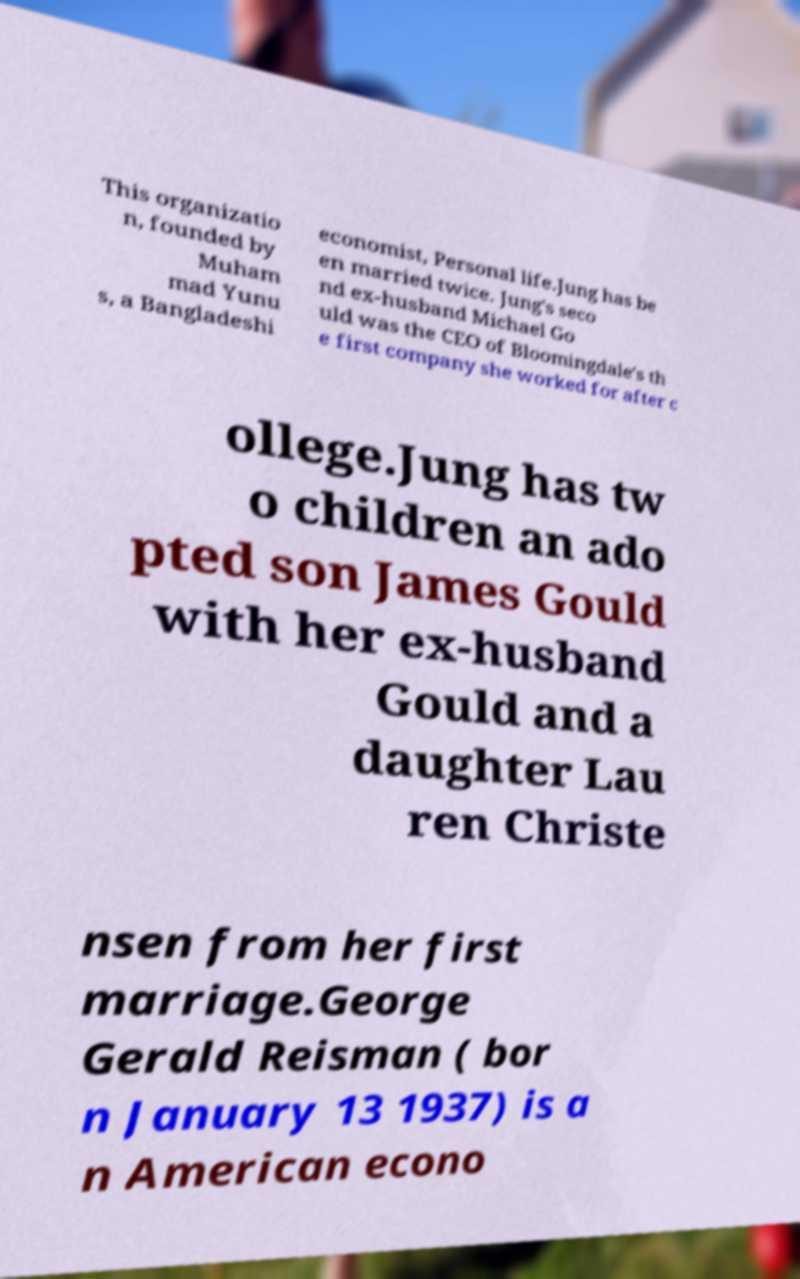Can you accurately transcribe the text from the provided image for me? This organizatio n, founded by Muham mad Yunu s, a Bangladeshi economist, Personal life.Jung has be en married twice. Jung's seco nd ex-husband Michael Go uld was the CEO of Bloomingdale's th e first company she worked for after c ollege.Jung has tw o children an ado pted son James Gould with her ex-husband Gould and a daughter Lau ren Christe nsen from her first marriage.George Gerald Reisman ( bor n January 13 1937) is a n American econo 